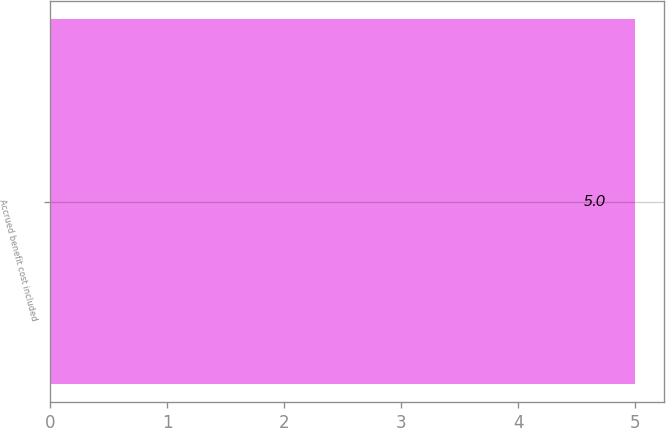Convert chart to OTSL. <chart><loc_0><loc_0><loc_500><loc_500><bar_chart><fcel>Accrued benefit cost included<nl><fcel>5<nl></chart> 